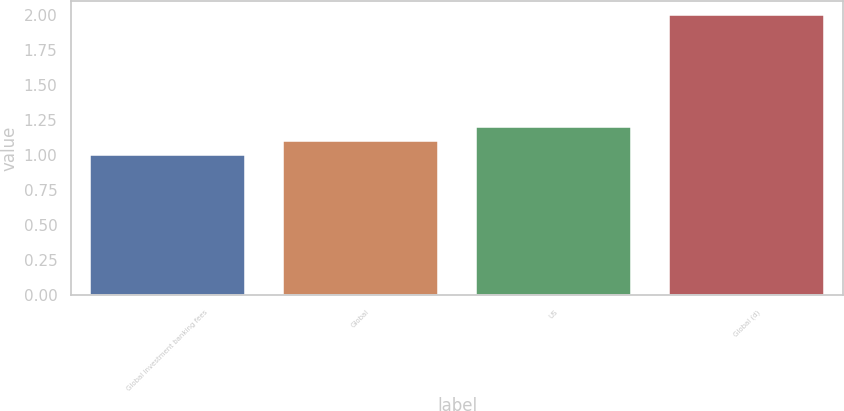<chart> <loc_0><loc_0><loc_500><loc_500><bar_chart><fcel>Global investment banking fees<fcel>Global<fcel>US<fcel>Global (d)<nl><fcel>1<fcel>1.1<fcel>1.2<fcel>2<nl></chart> 